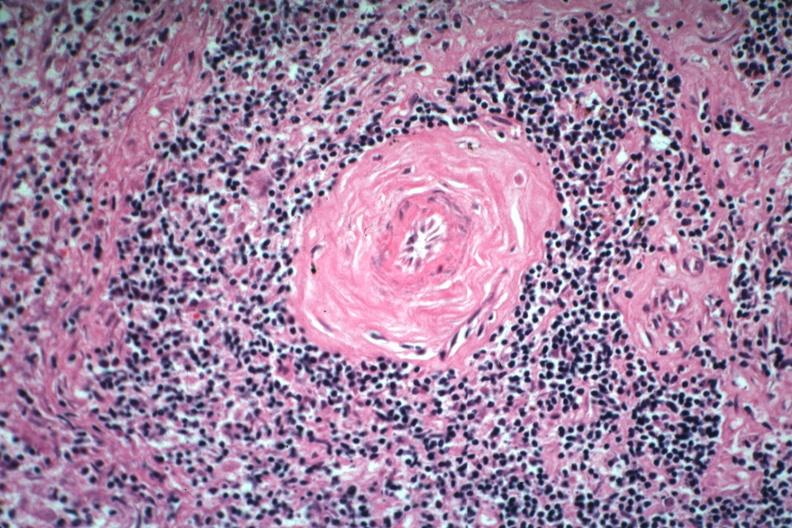s lupus erythematosus periarterial fibrosis present?
Answer the question using a single word or phrase. Yes 